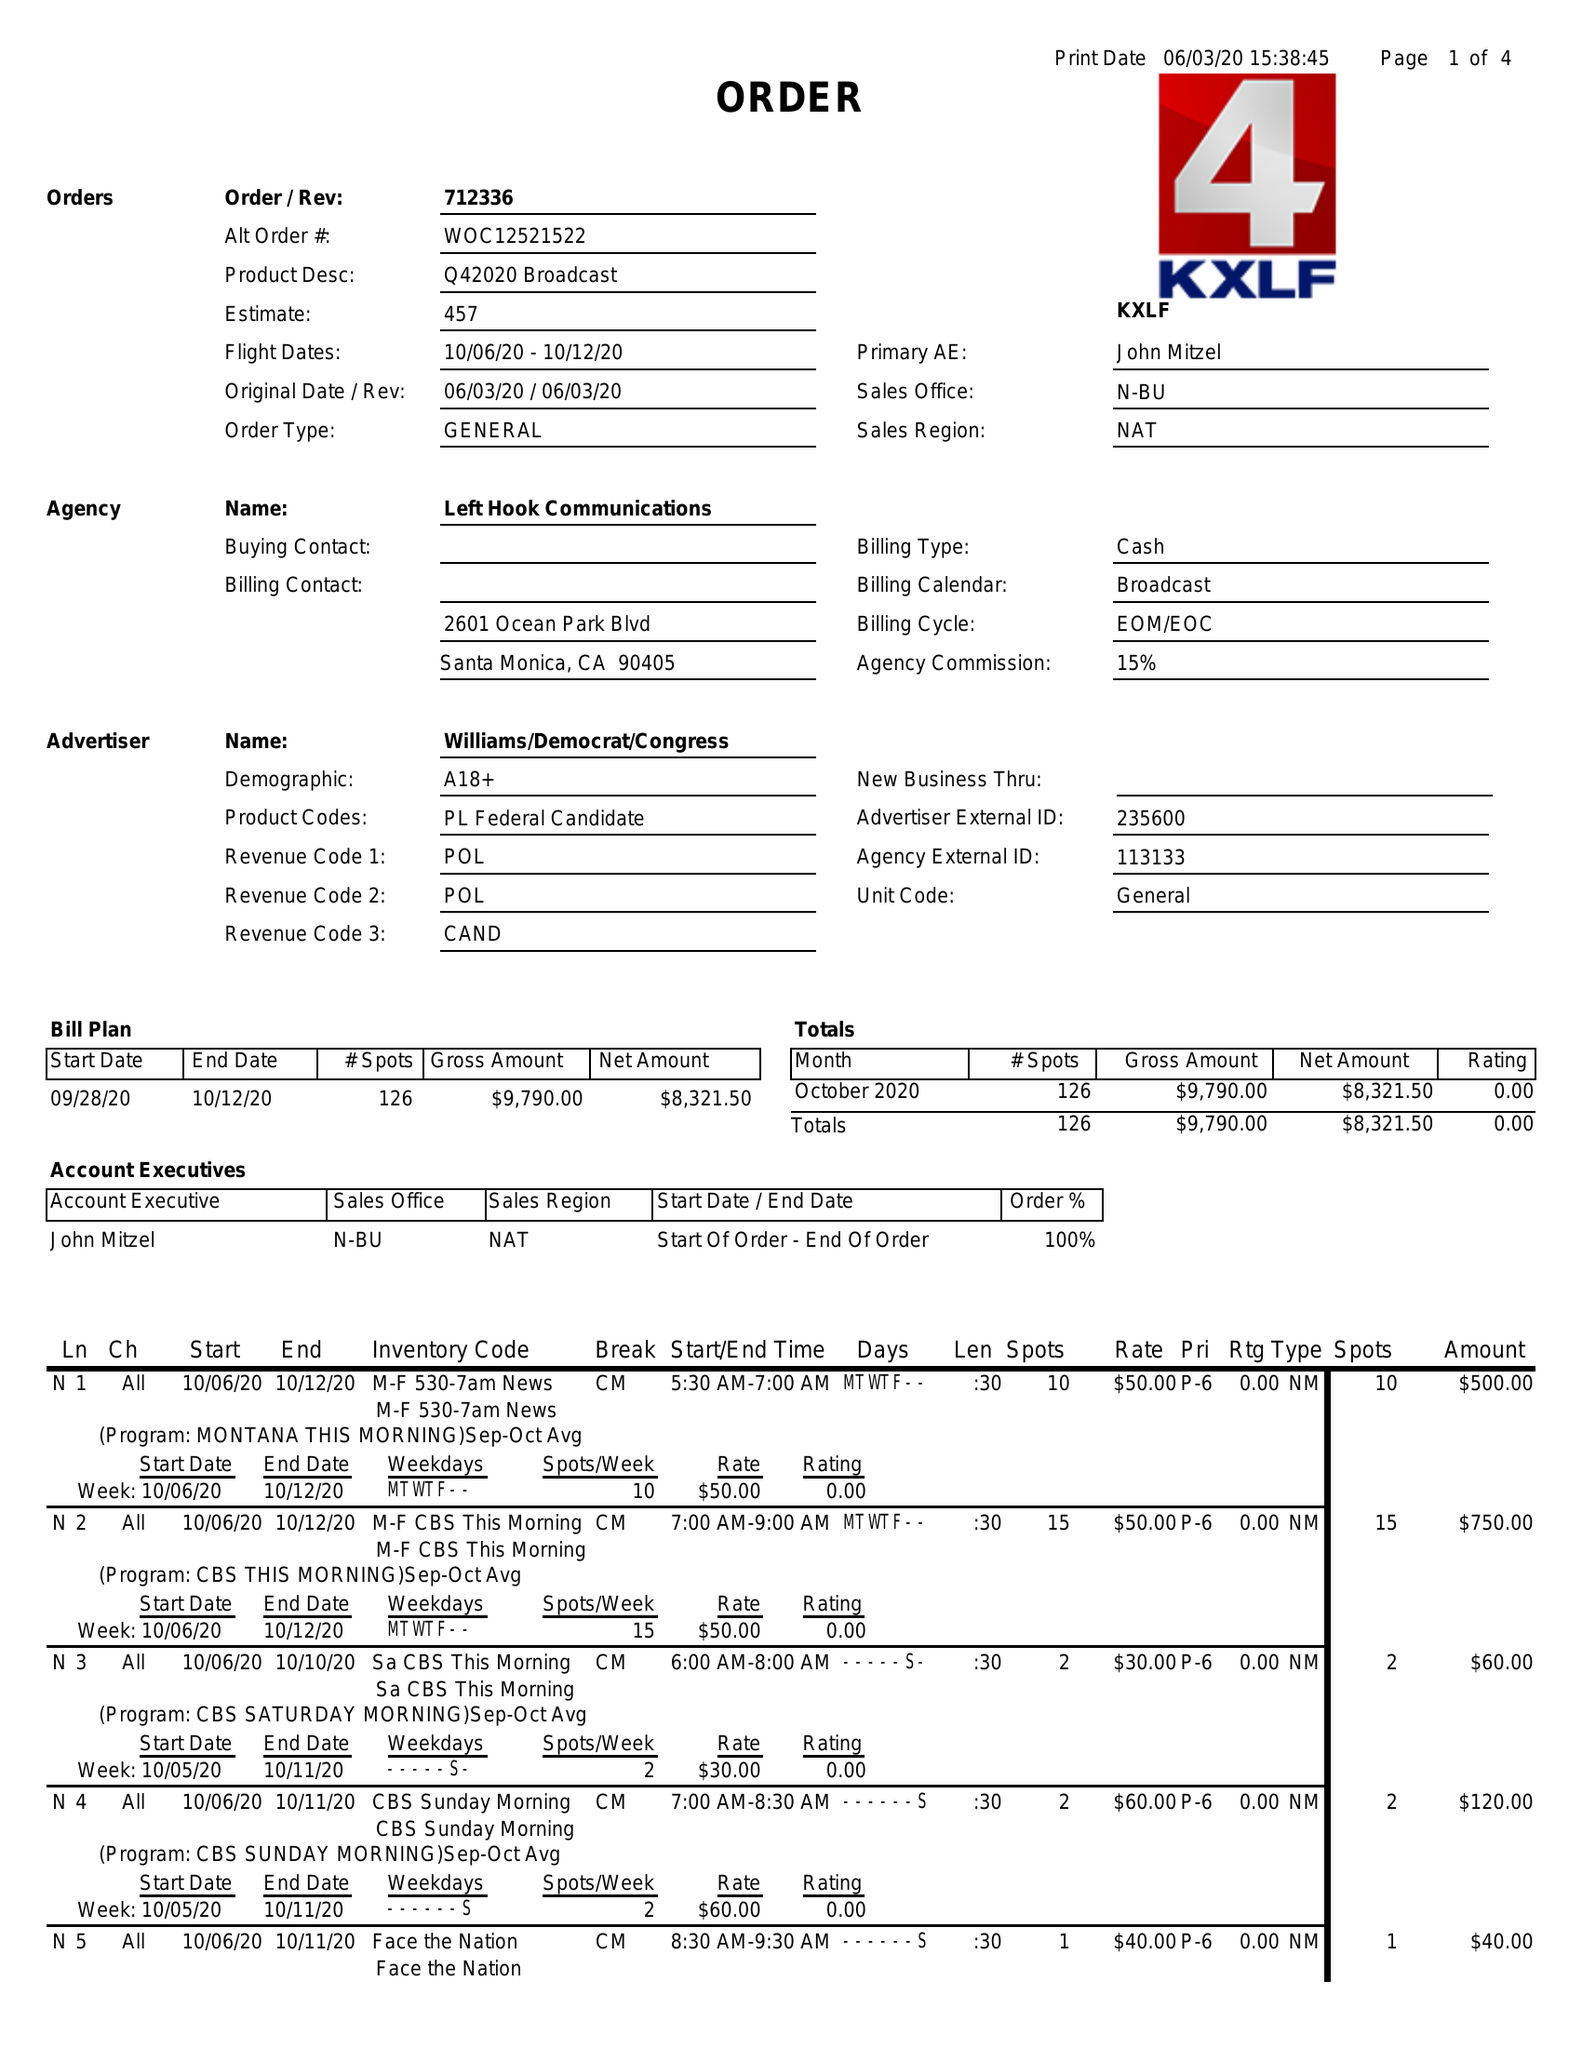What is the value for the contract_num?
Answer the question using a single word or phrase. 712336 